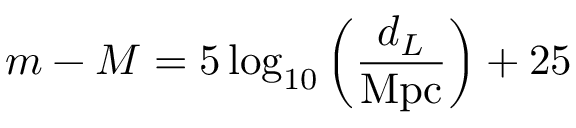Convert formula to latex. <formula><loc_0><loc_0><loc_500><loc_500>m - M = 5 \log _ { 1 0 } \left ( \frac { d _ { L } } { M p c } \right ) + 2 5</formula> 